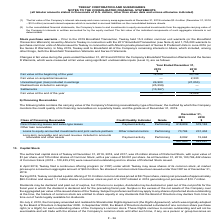According to Teekay Corporation's financial document, What was the fair value at the end of the year in 2018? According to the financial document, 12,026 (in thousands). The relevant text states: "Fair value at the beginning of the year 12,026 30,749..." Also, When did Teekay sell to Brookfield all of the Company’s remaining interests in Altera? According to the financial document, May 2019. The relevant text states: "nits in June 2016 (or the Series D Warrants ). In May 2019, Teekay sold to Brookfield all of the Company’s remaining interests in Altera, which included, amon..." Also, What was the Fair value at the beginning of the year for 2019 and 2018 respectively? The document shows two values: 12,026 and 30,749 (in thousands). From the document: "Fair value at the beginning of the year 12,026 30,749 Fair value at the beginning of the year 12,026 30,749..." Additionally, In which year was Fair value at the beginning of the year less than 15,000 thousands? According to the financial document, 2019. The relevant text states: "nd cross currency swap agreements at December 31, 2019 includes $3.4 million (December 31, 2018 – $3.2 million) accrued interest expense which is recorded..." Also, can you calculate: What is the average Fair value on acquisition/issuance for 2018 and 2019? To answer this question, I need to perform calculations using the financial data. The calculation is: (0 + 2,330) / 2, which equals 1165 (in thousands). This is based on the information: "Fair value on acquisition/issuance — 2,330 Fair value on acquisition/issuance — 2,330..." The key data points involved are: 0, 2,330. Also, can you calculate: What is the change in the Fair value at the end of the year from 2018 to 2019? Based on the calculation: 0 - 12,026, the result is -12026 (in thousands). This is based on the information: "Fair value at the beginning of the year 12,026 30,749 Fair value at the beginning of the year 12,026 30,749..." The key data points involved are: 12,026. 